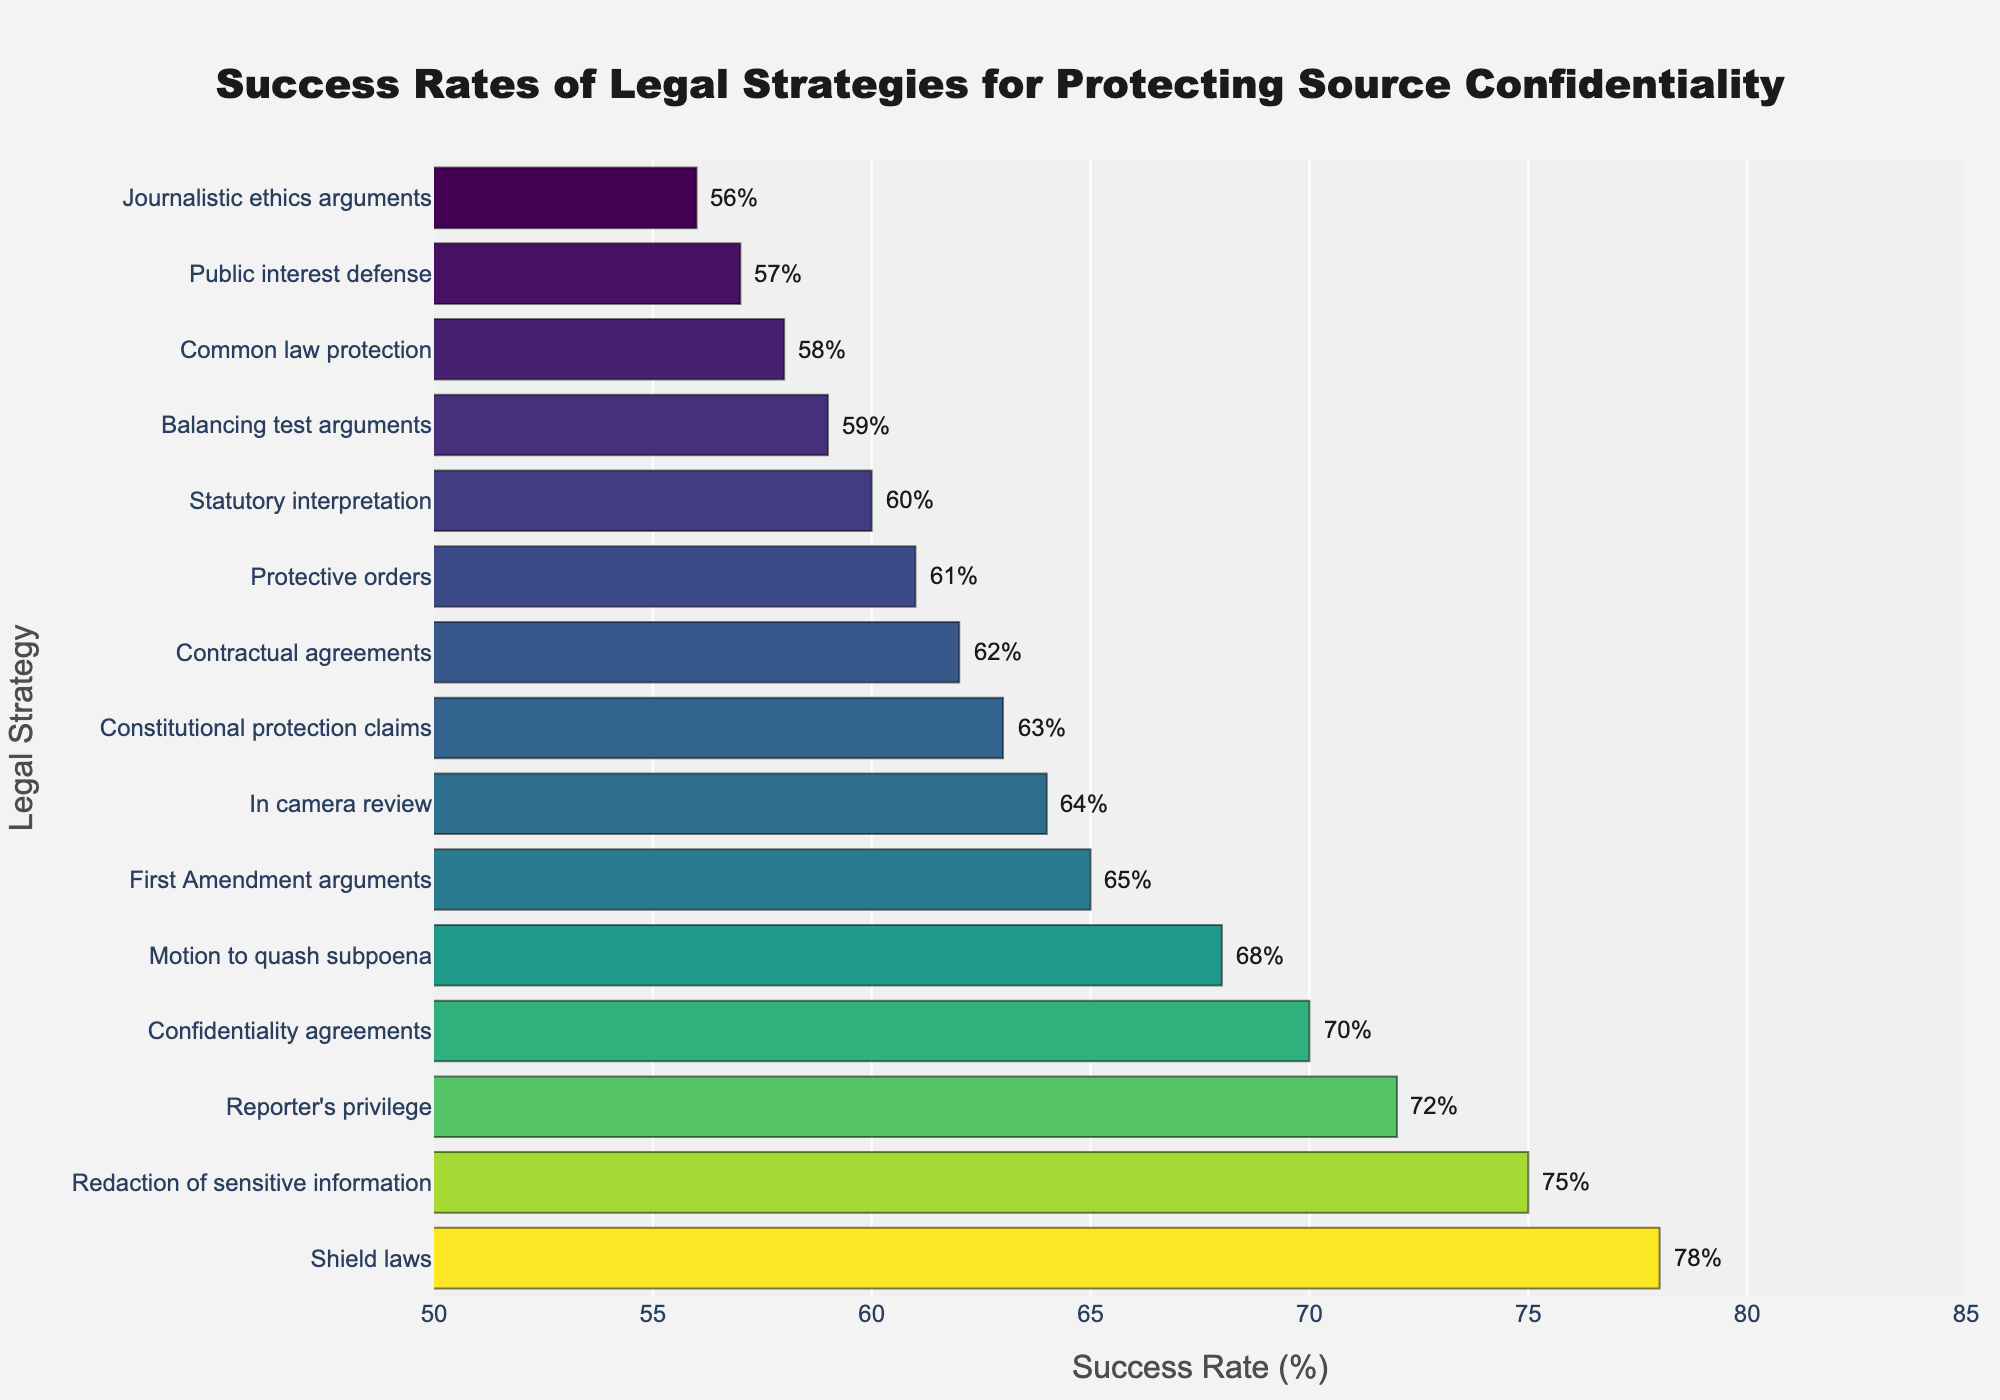Which legal strategy has the highest success rate? The bar chart shows that 'Shield laws' has the highest success rate at the top of the list.
Answer: Shield laws Which legal strategy has the lowest success rate? The bar chart shows that 'Journalistic ethics arguments' has the lowest success rate at the bottom of the list.
Answer: Journalistic ethics arguments What is the success rate difference between 'Shield laws' and 'First Amendment arguments'? 'Shield laws' has a success rate of 78% and 'First Amendment arguments' has a success rate of 65%. The difference can be calculated as 78 - 65 = 13%.
Answer: 13% What is the average success rate of 'Reporter's privilege', 'Confidentiality agreements', and 'Redaction of sensitive information'? Add the success rates of 'Reporter's privilege' (72%), 'Confidentiality agreements' (70%), and 'Redaction of sensitive information' (75%) and divide by 3: (72 + 70 + 75) / 3 = 217 / 3 = 72.3%.
Answer: 72.3% How many legal strategies have a success rate higher than 65%? The legal strategies climbing above 65% are 'Shield laws', 'Redaction of sensitive information', 'Reporter's privilege', 'Confidentiality agreements', and 'Motion to quash subpoena'. There are 5 strategies in total.
Answer: 5 Is 'Protective orders' more successful than 'Statutory interpretation'? 'Protective orders' has a success rate of 61%, while 'Statutory interpretation' has a success rate of 60%. Hence, 'Protective orders' has a slightly higher success rate.
Answer: Yes What is the cumulative success rate of 'Shield laws', 'In camera review', and 'Public interest defense'? Add together the success rates for these strategies: 78% (Shield laws) + 64% (In camera review) + 57% (Public interest defense) = 199%.
Answer: 199% Is there any strategy with a success rate of exactly 62%? The bar chart indicates that 'Contractual agreements' has a success rate of 62%.
Answer: Yes Compare the visual length of bars for 'Shield laws' and 'Motion to quash subpoena': which one is longer? Visually, the bar for 'Shield laws' extends to 78%, whereas the bar for 'Motion to quash subpoena' reaches 68%. Thus, the bar for 'Shield laws' is longer.
Answer: Shield laws Out of 'Common law protection', 'Confidentiality agreements', and 'Statutory interpretation', which strategy has the median success rate? Between 'Common law protection' (58%), 'Confidentiality agreements' (70%), and 'Statutory interpretation' (60%), 'Statutory interpretation' has the median success rate as it lies in the middle when ordered.
Answer: Statutory interpretation 